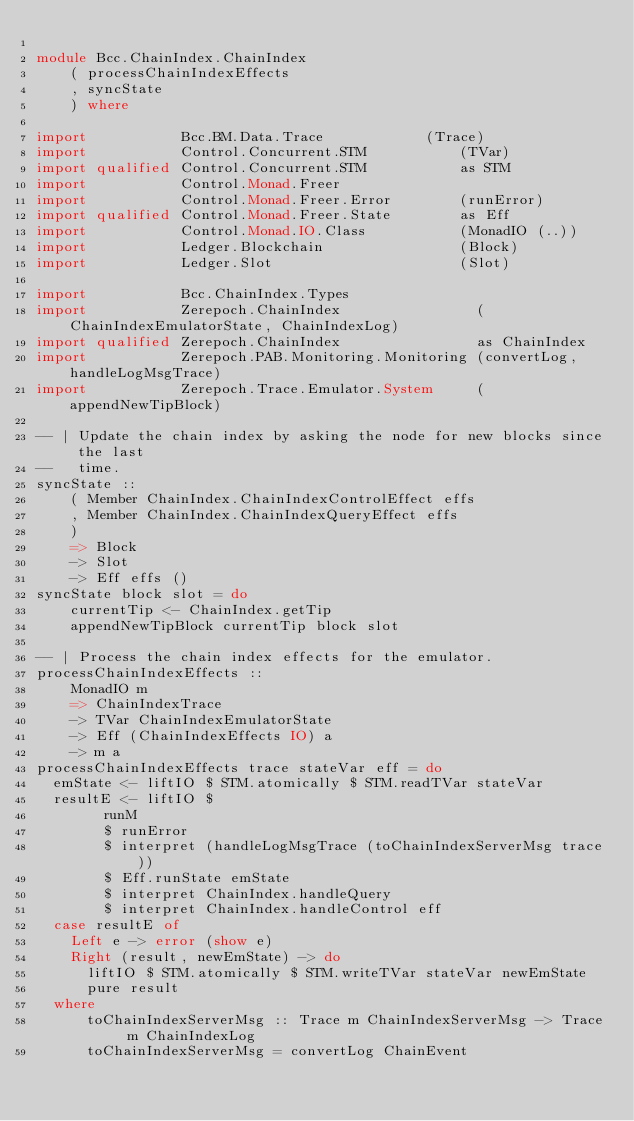<code> <loc_0><loc_0><loc_500><loc_500><_Haskell_>
module Bcc.ChainIndex.ChainIndex
    ( processChainIndexEffects
    , syncState
    ) where

import           Bcc.BM.Data.Trace            (Trace)
import           Control.Concurrent.STM           (TVar)
import qualified Control.Concurrent.STM           as STM
import           Control.Monad.Freer
import           Control.Monad.Freer.Error        (runError)
import qualified Control.Monad.Freer.State        as Eff
import           Control.Monad.IO.Class           (MonadIO (..))
import           Ledger.Blockchain                (Block)
import           Ledger.Slot                      (Slot)

import           Bcc.ChainIndex.Types
import           Zerepoch.ChainIndex                (ChainIndexEmulatorState, ChainIndexLog)
import qualified Zerepoch.ChainIndex                as ChainIndex
import           Zerepoch.PAB.Monitoring.Monitoring (convertLog, handleLogMsgTrace)
import           Zerepoch.Trace.Emulator.System     (appendNewTipBlock)

-- | Update the chain index by asking the node for new blocks since the last
--   time.
syncState ::
    ( Member ChainIndex.ChainIndexControlEffect effs
    , Member ChainIndex.ChainIndexQueryEffect effs
    )
    => Block
    -> Slot
    -> Eff effs ()
syncState block slot = do
    currentTip <- ChainIndex.getTip
    appendNewTipBlock currentTip block slot

-- | Process the chain index effects for the emulator.
processChainIndexEffects ::
    MonadIO m
    => ChainIndexTrace
    -> TVar ChainIndexEmulatorState
    -> Eff (ChainIndexEffects IO) a
    -> m a
processChainIndexEffects trace stateVar eff = do
  emState <- liftIO $ STM.atomically $ STM.readTVar stateVar
  resultE <- liftIO $
        runM
        $ runError
        $ interpret (handleLogMsgTrace (toChainIndexServerMsg trace))
        $ Eff.runState emState
        $ interpret ChainIndex.handleQuery
        $ interpret ChainIndex.handleControl eff
  case resultE of
    Left e -> error (show e)
    Right (result, newEmState) -> do
      liftIO $ STM.atomically $ STM.writeTVar stateVar newEmState
      pure result
  where
      toChainIndexServerMsg :: Trace m ChainIndexServerMsg -> Trace m ChainIndexLog
      toChainIndexServerMsg = convertLog ChainEvent
</code> 